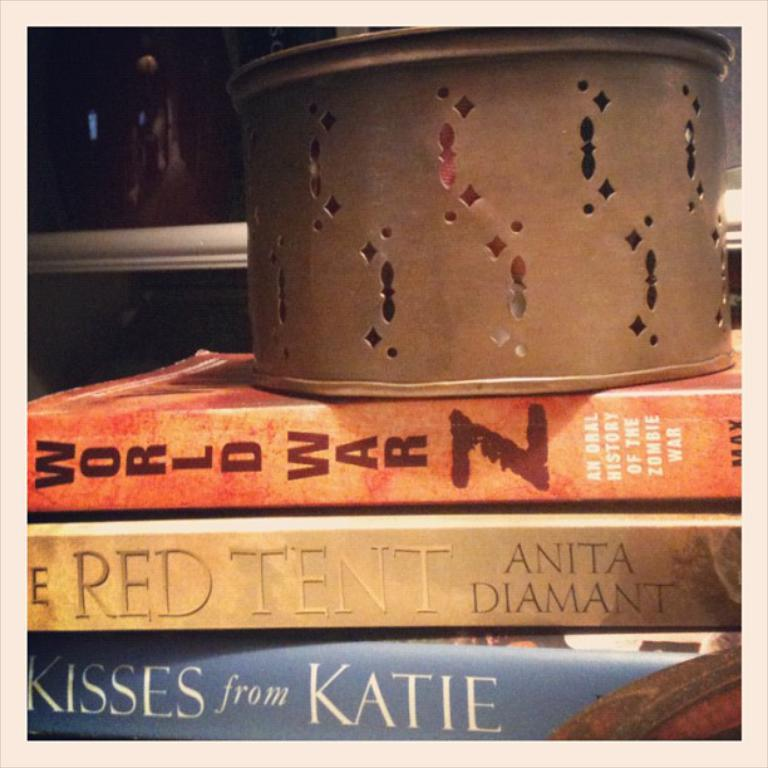<image>
Describe the image concisely. The book The Red Tent is in a pile with a tin on top. 